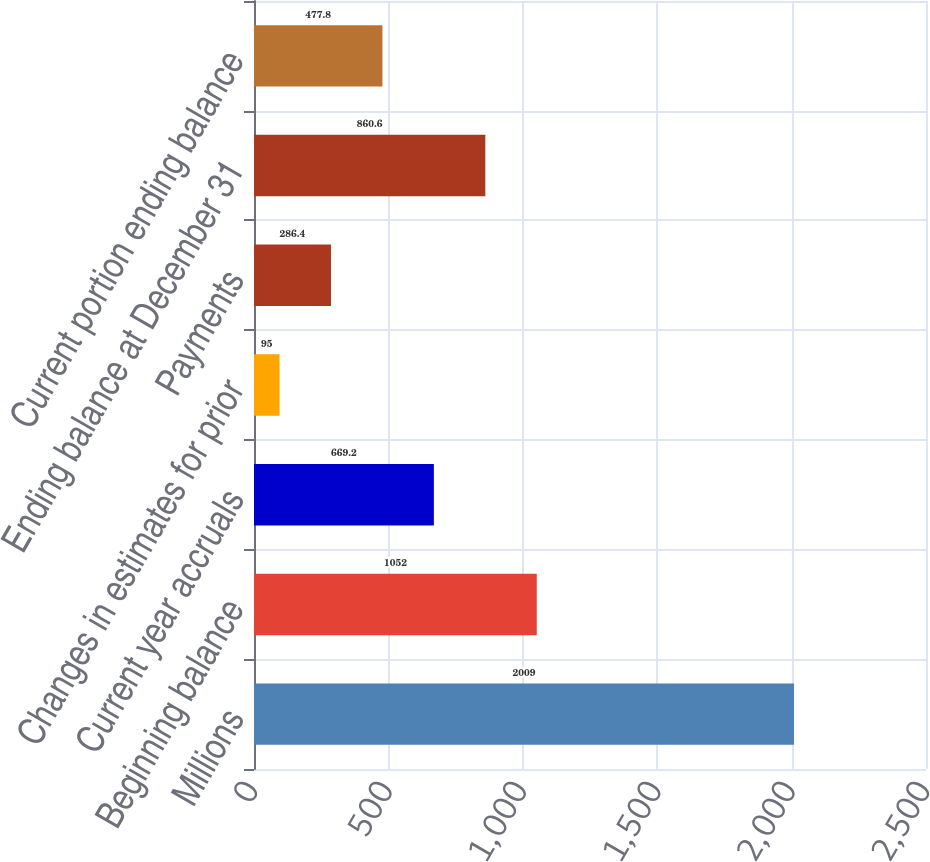Convert chart. <chart><loc_0><loc_0><loc_500><loc_500><bar_chart><fcel>Millions<fcel>Beginning balance<fcel>Current year accruals<fcel>Changes in estimates for prior<fcel>Payments<fcel>Ending balance at December 31<fcel>Current portion ending balance<nl><fcel>2009<fcel>1052<fcel>669.2<fcel>95<fcel>286.4<fcel>860.6<fcel>477.8<nl></chart> 